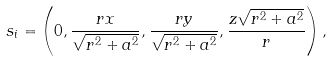Convert formula to latex. <formula><loc_0><loc_0><loc_500><loc_500>s _ { i } = \left ( 0 , \frac { r x } { \sqrt { r ^ { 2 } + a ^ { 2 } } } , \frac { r y } { \sqrt { r ^ { 2 } + a ^ { 2 } } } , \frac { z \sqrt { r ^ { 2 } + a ^ { 2 } } } { r } \right ) ,</formula> 